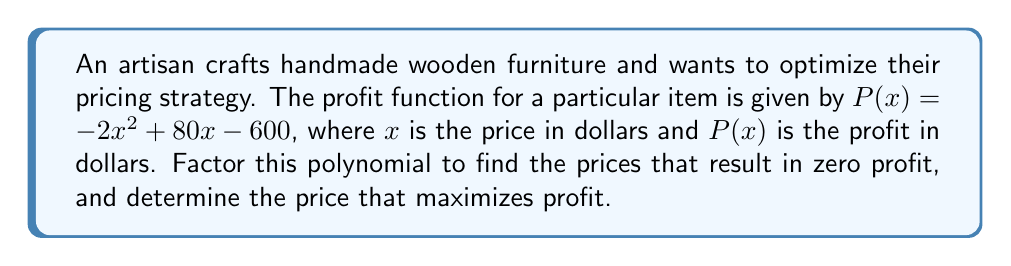Can you solve this math problem? 1. First, let's factor the polynomial $P(x) = -2x^2 + 80x - 600$:

   $P(x) = -2(x^2 - 40x + 300)$
   $P(x) = -2(x - 10)(x - 30)$

2. The zeros of the profit function occur when $P(x) = 0$:
   
   $-2(x - 10)(x - 30) = 0$
   $x = 10$ or $x = 30$

   This means the artisan breaks even (zero profit) when pricing the item at $10 or $30.

3. To find the price that maximizes profit, we need to find the vertex of the parabola. Since the polynomial is in the form $a(x-h)^2 + k$, we can use the formula $x = -b/(2a)$ to find the x-coordinate of the vertex:

   $x = -80/(-4) = 20$

4. Therefore, the price that maximizes profit is $20.

5. We can verify this by substituting $x = 20$ into the original function:

   $P(20) = -2(20)^2 + 80(20) - 600$
   $P(20) = -800 + 1600 - 600 = 200$

   This is indeed the maximum profit, as it's higher than the profit at $x = 10$ or $x = 30$ (which is zero).
Answer: Break-even prices: $10 and $30; Maximum profit price: $20 